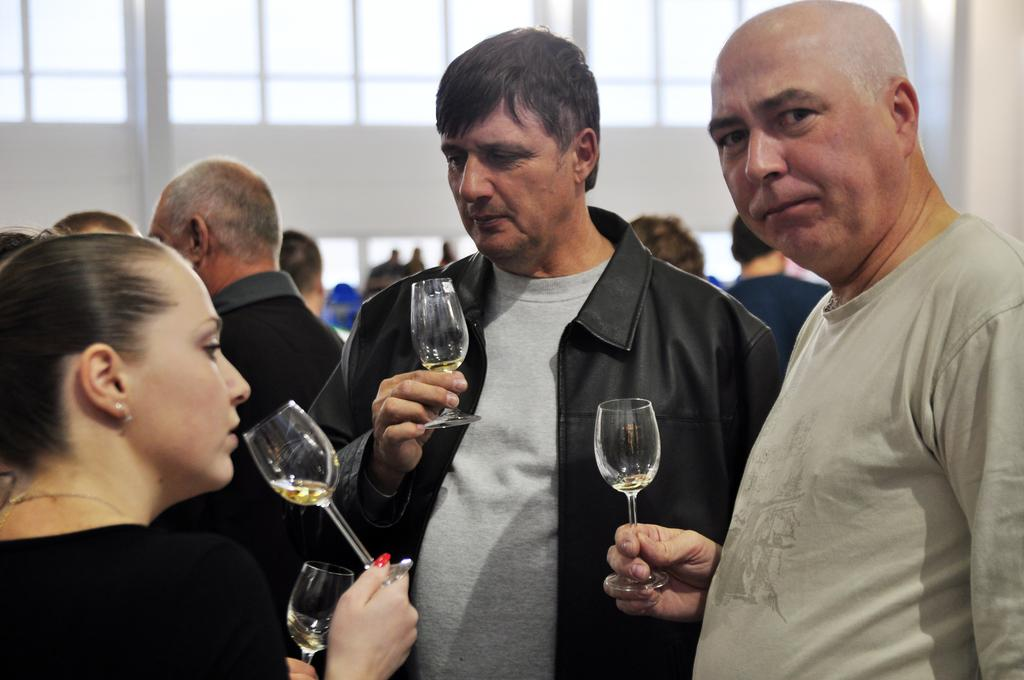How many people are in the image? There is a group of people in the image. What are the people in the image doing? The people are standing and holding glasses of wine. What can be seen in the background of the image? There is a building and another group of people in the background of the image. What type of rifle is the cook using to prepare the meal in the image? There is no cook or rifle present in the image; it features a group of people holding glasses of wine. 